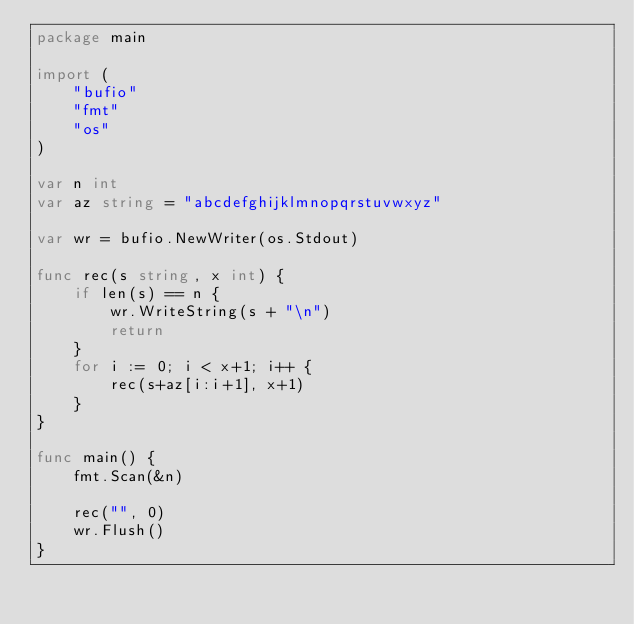Convert code to text. <code><loc_0><loc_0><loc_500><loc_500><_Go_>package main

import (
	"bufio"
	"fmt"
	"os"
)

var n int
var az string = "abcdefghijklmnopqrstuvwxyz"

var wr = bufio.NewWriter(os.Stdout)

func rec(s string, x int) {
	if len(s) == n {
		wr.WriteString(s + "\n")
		return
	}
	for i := 0; i < x+1; i++ {
		rec(s+az[i:i+1], x+1)
	}
}

func main() {
	fmt.Scan(&n)

	rec("", 0)
	wr.Flush()
}
</code> 